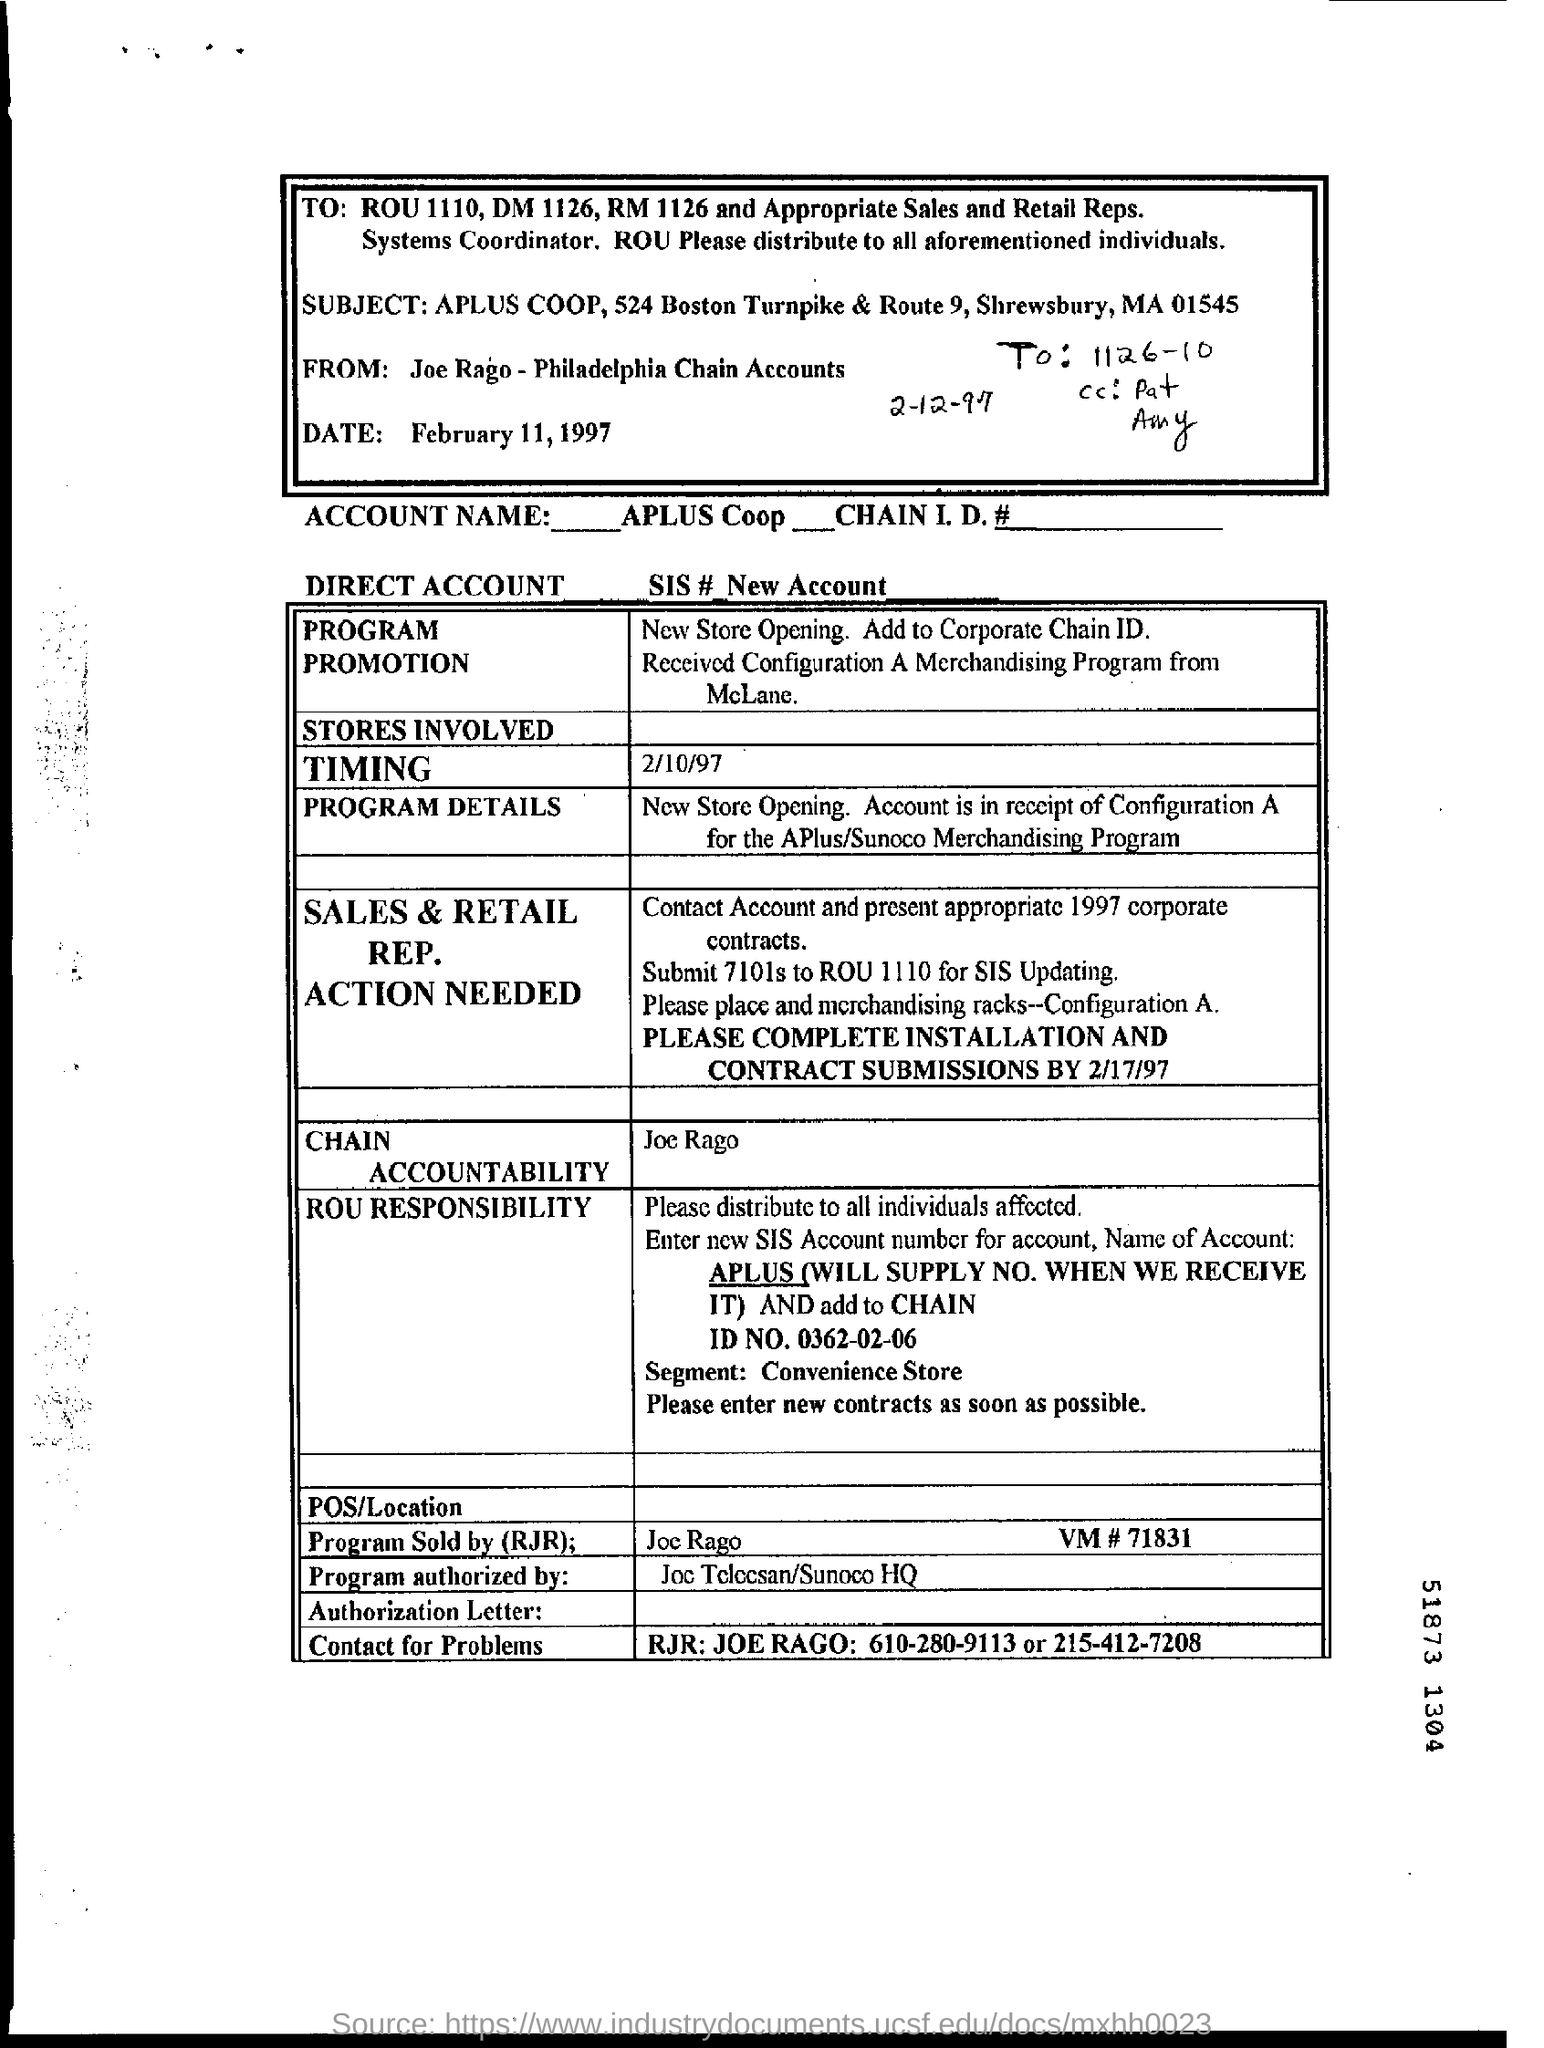Who sold the program?
Make the answer very short. RJR. When is the form dated?
Make the answer very short. February 11, 1997. 